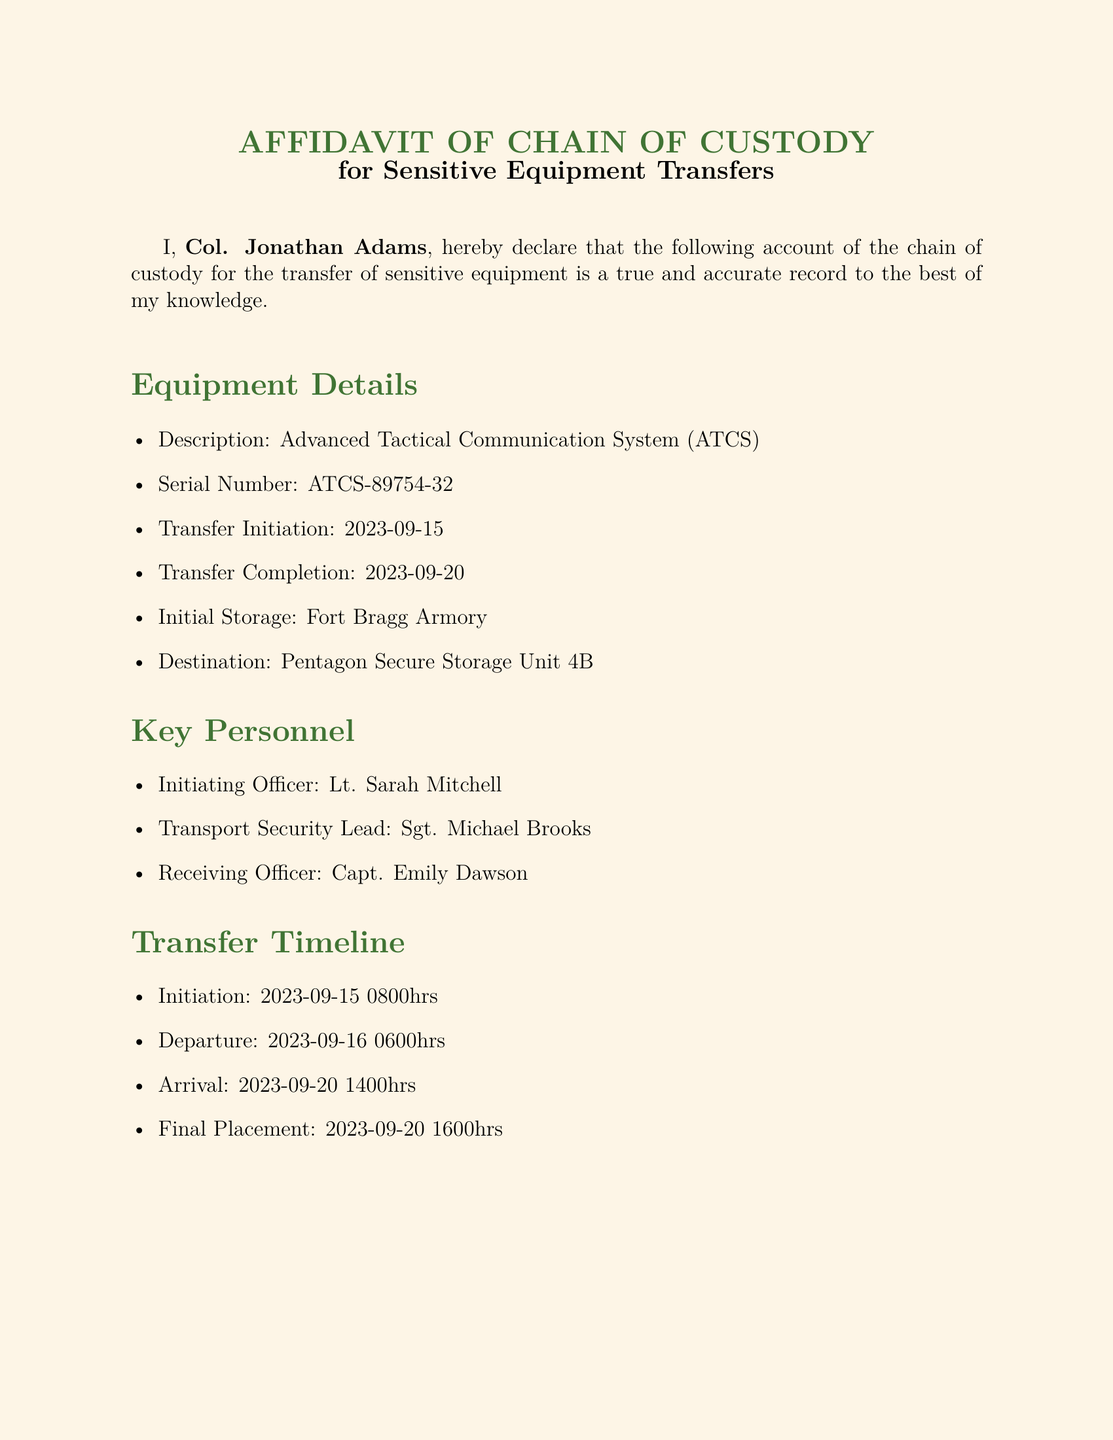What is the serial number of the equipment? The serial number is specified in the document under Equipment Details.
Answer: ATCS-89754-32 Who is the initiating officer? The initiating officer is listed among the Key Personnel involved in the transfer.
Answer: Lt. Sarah Mitchell On what date did the transfer initiation occur? The transfer initiation date is indicated under Equipment Details in the document.
Answer: 2023-09-15 What security measure was implemented for transport? Security measures are detailed in a specific section, including various protocols.
Answer: Tamper-evident sealed containers What was the final placement time of the equipment? The final placement time is part of the Transfer Timeline section in the document.
Answer: 2023-09-20 1600hrs What is the destination of the equipment? The destination is clearly stated within the Equipment Details.
Answer: Pentagon Secure Storage Unit 4B How many days did the transfer take? The transfer duration can be calculated from the initiation and completion dates provided.
Answer: 5 days What type of transport vehicle was used? The type of transport vehicle is mentioned in the Security Measures section.
Answer: Military-grade armored transport vehicle Who notarized the document? The notarization is specifically credited to an individual at the end of the document.
Answer: Karen Foster 